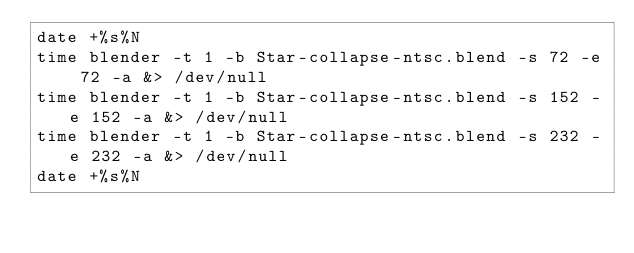<code> <loc_0><loc_0><loc_500><loc_500><_Bash_>date +%s%N
time blender -t 1 -b Star-collapse-ntsc.blend -s 72 -e 72 -a &> /dev/null
time blender -t 1 -b Star-collapse-ntsc.blend -s 152 -e 152 -a &> /dev/null
time blender -t 1 -b Star-collapse-ntsc.blend -s 232 -e 232 -a &> /dev/null
date +%s%N
</code> 